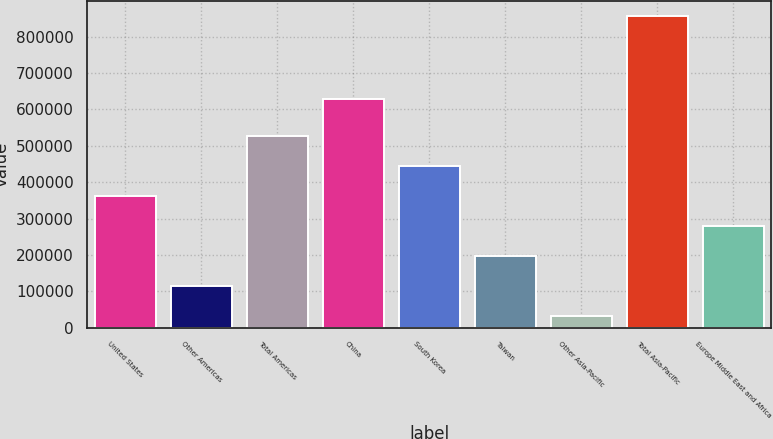<chart> <loc_0><loc_0><loc_500><loc_500><bar_chart><fcel>United States<fcel>Other Americas<fcel>Total Americas<fcel>China<fcel>South Korea<fcel>Taiwan<fcel>Other Asia-Pacific<fcel>Total Asia-Pacific<fcel>Europe Middle East and Africa<nl><fcel>360910<fcel>113419<fcel>525903<fcel>628858<fcel>443406<fcel>195916<fcel>30922<fcel>855891<fcel>278413<nl></chart> 